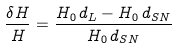Convert formula to latex. <formula><loc_0><loc_0><loc_500><loc_500>\frac { \delta H } { H } = \frac { H _ { 0 } \, d _ { L } - H _ { 0 } \, d _ { S N } } { H _ { 0 } \, d _ { S N } }</formula> 